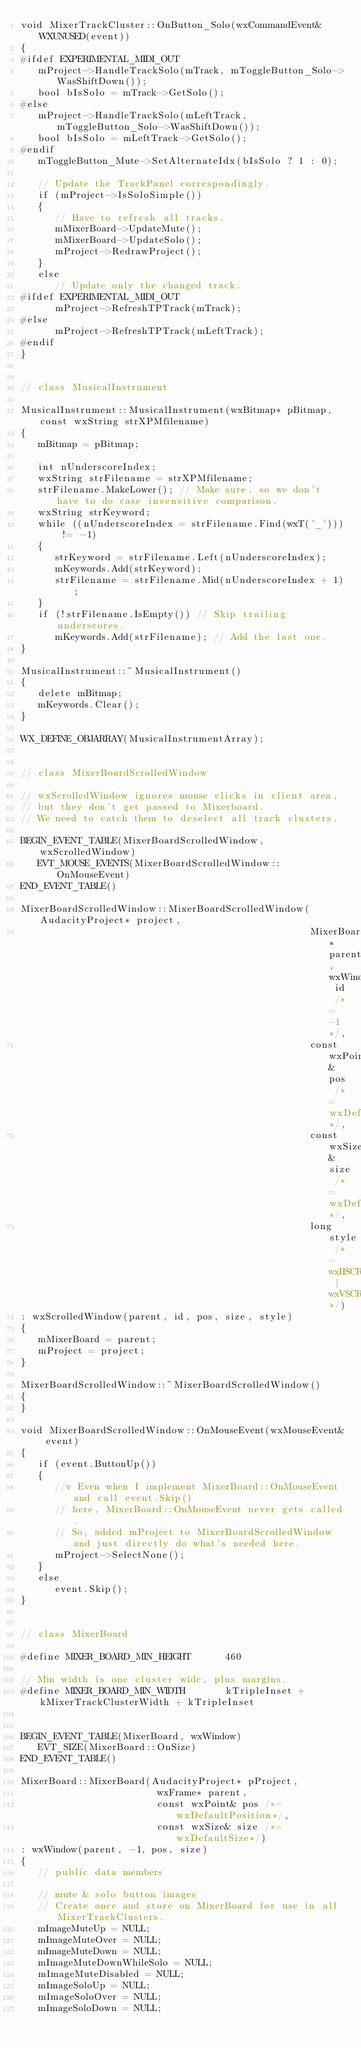<code> <loc_0><loc_0><loc_500><loc_500><_C++_>void MixerTrackCluster::OnButton_Solo(wxCommandEvent& WXUNUSED(event))
{
#ifdef EXPERIMENTAL_MIDI_OUT
   mProject->HandleTrackSolo(mTrack, mToggleButton_Solo->WasShiftDown());
   bool bIsSolo = mTrack->GetSolo();
#else
   mProject->HandleTrackSolo(mLeftTrack, mToggleButton_Solo->WasShiftDown());
   bool bIsSolo = mLeftTrack->GetSolo();
#endif
   mToggleButton_Mute->SetAlternateIdx(bIsSolo ? 1 : 0);

   // Update the TrackPanel correspondingly.
   if (mProject->IsSoloSimple())
   {
      // Have to refresh all tracks.
      mMixerBoard->UpdateMute();
      mMixerBoard->UpdateSolo();
      mProject->RedrawProject();
   }
   else
      // Update only the changed track.
#ifdef EXPERIMENTAL_MIDI_OUT
      mProject->RefreshTPTrack(mTrack);
#else
      mProject->RefreshTPTrack(mLeftTrack);
#endif
}


// class MusicalInstrument

MusicalInstrument::MusicalInstrument(wxBitmap* pBitmap, const wxString strXPMfilename)
{
   mBitmap = pBitmap;

   int nUnderscoreIndex;
   wxString strFilename = strXPMfilename;
   strFilename.MakeLower(); // Make sure, so we don't have to do case insensitive comparison.
   wxString strKeyword;
   while ((nUnderscoreIndex = strFilename.Find(wxT('_'))) != -1)
   {
      strKeyword = strFilename.Left(nUnderscoreIndex);
      mKeywords.Add(strKeyword);
      strFilename = strFilename.Mid(nUnderscoreIndex + 1);
   }
   if (!strFilename.IsEmpty()) // Skip trailing underscores.
      mKeywords.Add(strFilename); // Add the last one.
}

MusicalInstrument::~MusicalInstrument()
{
   delete mBitmap;
   mKeywords.Clear();
}

WX_DEFINE_OBJARRAY(MusicalInstrumentArray);


// class MixerBoardScrolledWindow

// wxScrolledWindow ignores mouse clicks in client area,
// but they don't get passed to Mixerboard.
// We need to catch them to deselect all track clusters.

BEGIN_EVENT_TABLE(MixerBoardScrolledWindow, wxScrolledWindow)
   EVT_MOUSE_EVENTS(MixerBoardScrolledWindow::OnMouseEvent)
END_EVENT_TABLE()

MixerBoardScrolledWindow::MixerBoardScrolledWindow(AudacityProject* project,
                                                   MixerBoard* parent, wxWindowID id /*= -1*/,
                                                   const wxPoint& pos /*= wxDefaultPosition*/,
                                                   const wxSize& size /*= wxDefaultSize*/,
                                                   long style /*= wxHSCROLL | wxVSCROLL*/)
: wxScrolledWindow(parent, id, pos, size, style)
{
   mMixerBoard = parent;
   mProject = project;
}

MixerBoardScrolledWindow::~MixerBoardScrolledWindow()
{
}

void MixerBoardScrolledWindow::OnMouseEvent(wxMouseEvent& event)
{
   if (event.ButtonUp())
   {
      //v Even when I implement MixerBoard::OnMouseEvent and call event.Skip()
      // here, MixerBoard::OnMouseEvent never gets called.
      // So, added mProject to MixerBoardScrolledWindow and just directly do what's needed here.
      mProject->SelectNone();
   }
   else
      event.Skip();
}


// class MixerBoard

#define MIXER_BOARD_MIN_HEIGHT      460

// Min width is one cluster wide, plus margins.
#define MIXER_BOARD_MIN_WIDTH       kTripleInset + kMixerTrackClusterWidth + kTripleInset


BEGIN_EVENT_TABLE(MixerBoard, wxWindow)
   EVT_SIZE(MixerBoard::OnSize)
END_EVENT_TABLE()

MixerBoard::MixerBoard(AudacityProject* pProject,
                        wxFrame* parent,
                        const wxPoint& pos /*= wxDefaultPosition*/,
                        const wxSize& size /*= wxDefaultSize*/)
: wxWindow(parent, -1, pos, size)
{
   // public data members

   // mute & solo button images
   // Create once and store on MixerBoard for use in all MixerTrackClusters.
   mImageMuteUp = NULL;
   mImageMuteOver = NULL;
   mImageMuteDown = NULL;
   mImageMuteDownWhileSolo = NULL;
   mImageMuteDisabled = NULL;
   mImageSoloUp = NULL;
   mImageSoloOver = NULL;
   mImageSoloDown = NULL;</code> 